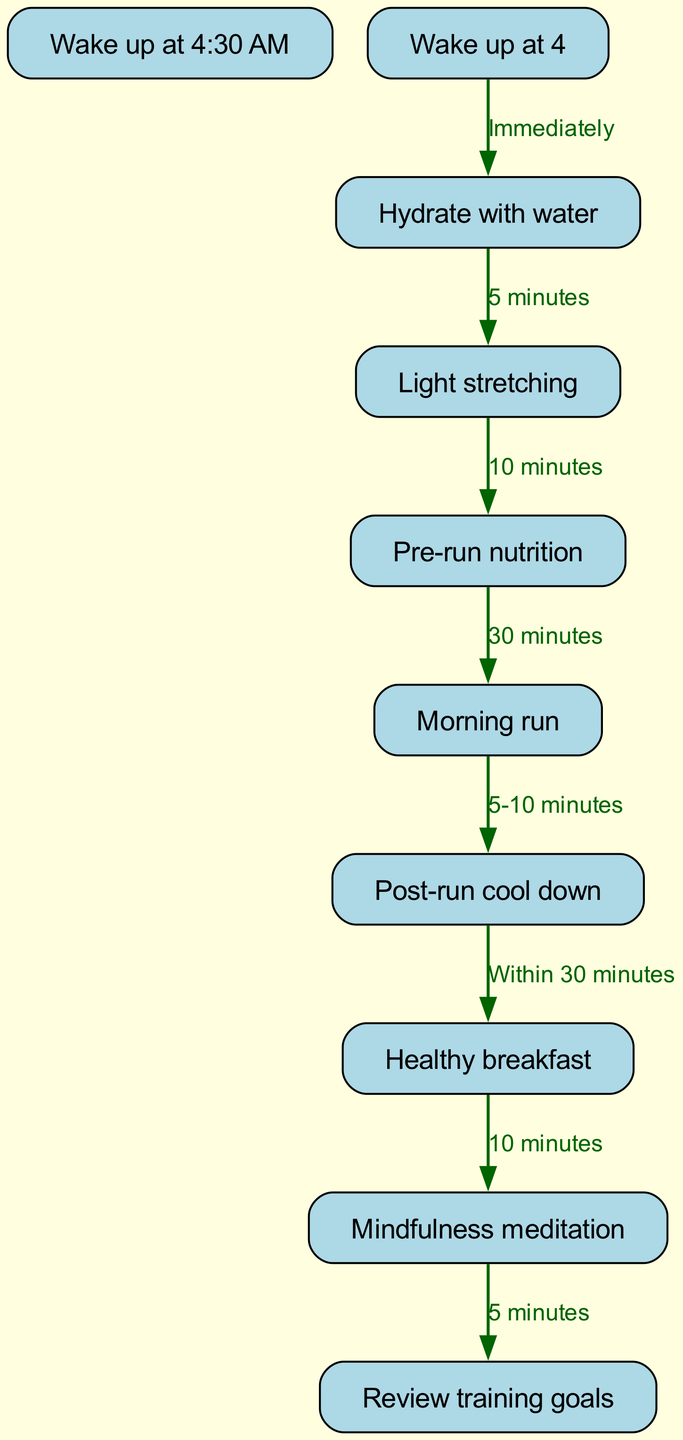What is the first step in the morning routine? The diagram indicates that the first step in the morning routine is "Wake up at 4:30 AM," as it is the topmost block.
Answer: Wake up at 4:30 AM How long does the light stretching last? The diagram connects "Light stretching" to "Pre-run nutrition," with a labeled duration of "10 minutes."
Answer: 10 minutes What follows immediately after hydrating with water? The diagram shows an immediate connection from "Hydrate with water" to "Light stretching," indicating that light stretching follows directly after.
Answer: Light stretching How many minutes are allocated for the morning run? The connection between "Pre-run nutrition" and "Morning run" is labeled "30 minutes," which indicates the allocated time for the morning run.
Answer: 30 minutes What is the time gap between post-run cool down and having a healthy breakfast? The diagram states that "Healthy breakfast" follows "Post-run cool down" within a time frame of "Within 30 minutes." This implies the breakfast should be consumed relatively quickly after the cool down.
Answer: Within 30 minutes What is the final activity in the morning routine? The last block in the sequence is "Review training goals," which indicates it is the final activity in the morning routine.
Answer: Review training goals How is mindfulness meditation integrated into the routine? Mindfulness meditation follows "Healthy breakfast" with a labeled duration of "10 minutes," indicating it is a well-defined part of the routine immediately following the meal.
Answer: 10 minutes How many total blocks are present in this morning routine diagram? By counting each individual block listed in the diagram, there are 9 blocks in total that represent different activities in the morning routine.
Answer: 9 